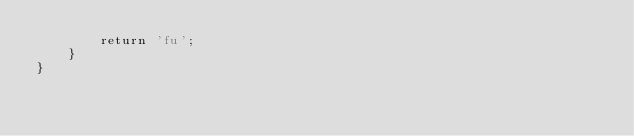Convert code to text. <code><loc_0><loc_0><loc_500><loc_500><_PHP_>        return 'fu';
    }
}</code> 